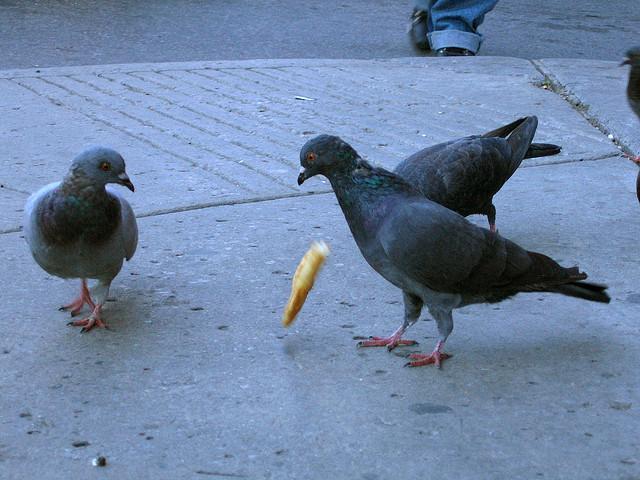How many birds are there?
Give a very brief answer. 3. 